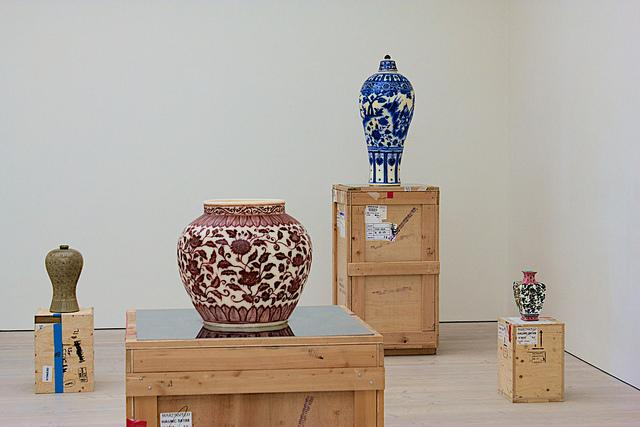What is the main color of the Chinese vase on the center right? blue 